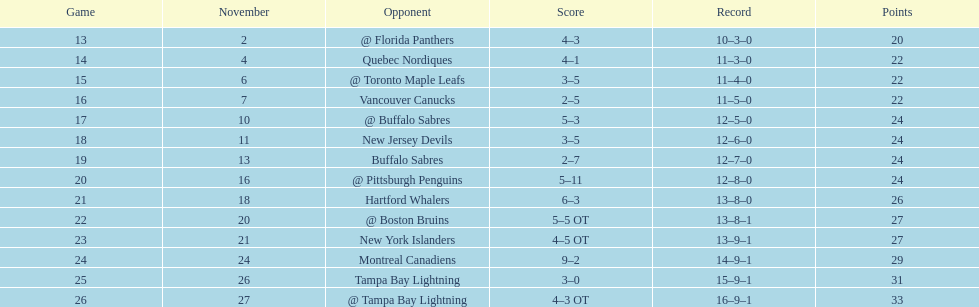Who recorded the highest number of assists for the flyers during the 1993-1994 season? Mark Recchi. 